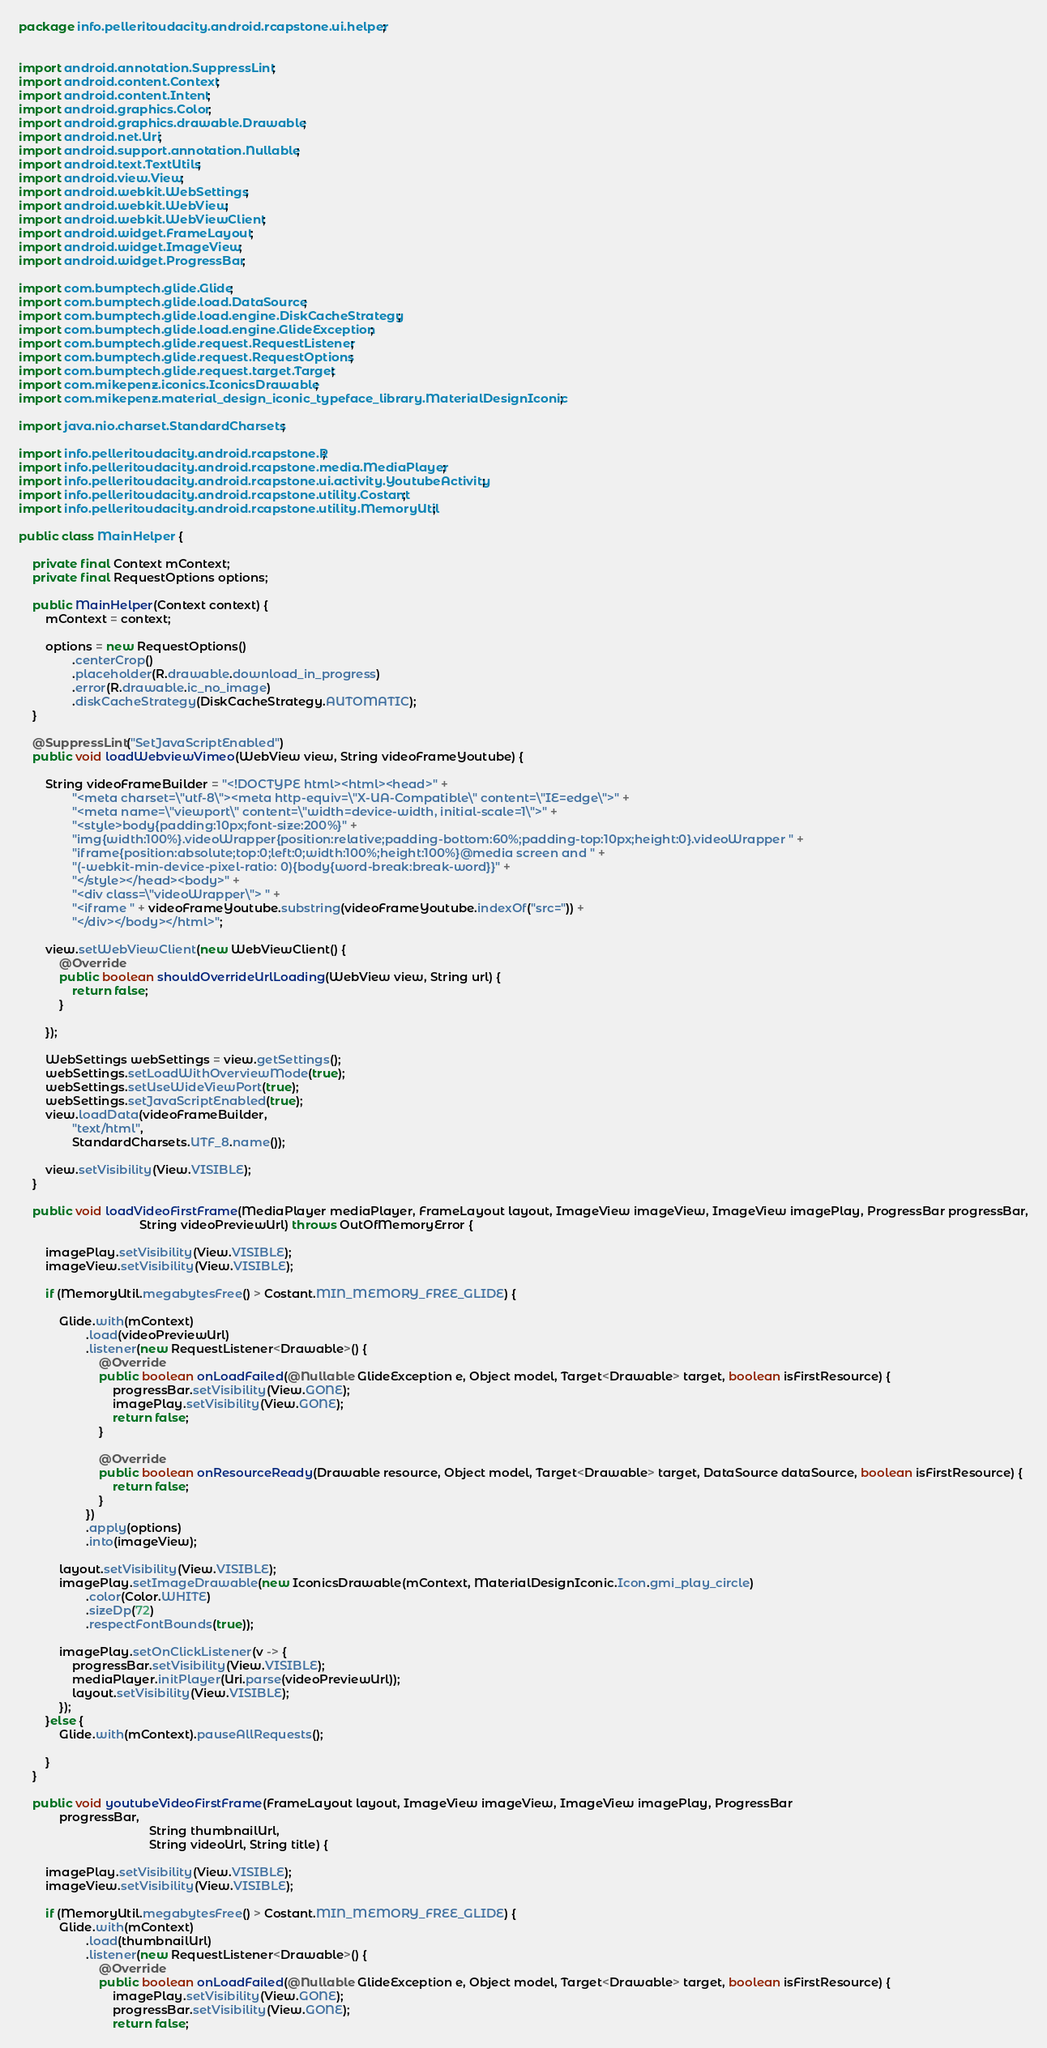<code> <loc_0><loc_0><loc_500><loc_500><_Java_>package info.pelleritoudacity.android.rcapstone.ui.helper;


import android.annotation.SuppressLint;
import android.content.Context;
import android.content.Intent;
import android.graphics.Color;
import android.graphics.drawable.Drawable;
import android.net.Uri;
import android.support.annotation.Nullable;
import android.text.TextUtils;
import android.view.View;
import android.webkit.WebSettings;
import android.webkit.WebView;
import android.webkit.WebViewClient;
import android.widget.FrameLayout;
import android.widget.ImageView;
import android.widget.ProgressBar;

import com.bumptech.glide.Glide;
import com.bumptech.glide.load.DataSource;
import com.bumptech.glide.load.engine.DiskCacheStrategy;
import com.bumptech.glide.load.engine.GlideException;
import com.bumptech.glide.request.RequestListener;
import com.bumptech.glide.request.RequestOptions;
import com.bumptech.glide.request.target.Target;
import com.mikepenz.iconics.IconicsDrawable;
import com.mikepenz.material_design_iconic_typeface_library.MaterialDesignIconic;

import java.nio.charset.StandardCharsets;

import info.pelleritoudacity.android.rcapstone.R;
import info.pelleritoudacity.android.rcapstone.media.MediaPlayer;
import info.pelleritoudacity.android.rcapstone.ui.activity.YoutubeActivity;
import info.pelleritoudacity.android.rcapstone.utility.Costant;
import info.pelleritoudacity.android.rcapstone.utility.MemoryUtil;

public class MainHelper {

    private final Context mContext;
    private final RequestOptions options;

    public MainHelper(Context context) {
        mContext = context;

        options = new RequestOptions()
                .centerCrop()
                .placeholder(R.drawable.download_in_progress)
                .error(R.drawable.ic_no_image)
                .diskCacheStrategy(DiskCacheStrategy.AUTOMATIC);
    }

    @SuppressLint("SetJavaScriptEnabled")
    public void loadWebviewVimeo(WebView view, String videoFrameYoutube) {

        String videoFrameBuilder = "<!DOCTYPE html><html><head>" +
                "<meta charset=\"utf-8\"><meta http-equiv=\"X-UA-Compatible\" content=\"IE=edge\">" +
                "<meta name=\"viewport\" content=\"width=device-width, initial-scale=1\">" +
                "<style>body{padding:10px;font-size:200%}" +
                "img{width:100%}.videoWrapper{position:relative;padding-bottom:60%;padding-top:10px;height:0}.videoWrapper " +
                "iframe{position:absolute;top:0;left:0;width:100%;height:100%}@media screen and " +
                "(-webkit-min-device-pixel-ratio: 0){body{word-break:break-word}}" +
                "</style></head><body>" +
                "<div class=\"videoWrapper\"> " +
                "<iframe " + videoFrameYoutube.substring(videoFrameYoutube.indexOf("src=")) +
                "</div></body></html>";

        view.setWebViewClient(new WebViewClient() {
            @Override
            public boolean shouldOverrideUrlLoading(WebView view, String url) {
                return false;
            }

        });

        WebSettings webSettings = view.getSettings();
        webSettings.setLoadWithOverviewMode(true);
        webSettings.setUseWideViewPort(true);
        webSettings.setJavaScriptEnabled(true);
        view.loadData(videoFrameBuilder,
                "text/html",
                StandardCharsets.UTF_8.name());

        view.setVisibility(View.VISIBLE);
    }

    public void loadVideoFirstFrame(MediaPlayer mediaPlayer, FrameLayout layout, ImageView imageView, ImageView imagePlay, ProgressBar progressBar,
                                    String videoPreviewUrl) throws OutOfMemoryError {

        imagePlay.setVisibility(View.VISIBLE);
        imageView.setVisibility(View.VISIBLE);

        if (MemoryUtil.megabytesFree() > Costant.MIN_MEMORY_FREE_GLIDE) {

            Glide.with(mContext)
                    .load(videoPreviewUrl)
                    .listener(new RequestListener<Drawable>() {
                        @Override
                        public boolean onLoadFailed(@Nullable GlideException e, Object model, Target<Drawable> target, boolean isFirstResource) {
                            progressBar.setVisibility(View.GONE);
                            imagePlay.setVisibility(View.GONE);
                            return false;
                        }

                        @Override
                        public boolean onResourceReady(Drawable resource, Object model, Target<Drawable> target, DataSource dataSource, boolean isFirstResource) {
                            return false;
                        }
                    })
                    .apply(options)
                    .into(imageView);

            layout.setVisibility(View.VISIBLE);
            imagePlay.setImageDrawable(new IconicsDrawable(mContext, MaterialDesignIconic.Icon.gmi_play_circle)
                    .color(Color.WHITE)
                    .sizeDp(72)
                    .respectFontBounds(true));

            imagePlay.setOnClickListener(v -> {
                progressBar.setVisibility(View.VISIBLE);
                mediaPlayer.initPlayer(Uri.parse(videoPreviewUrl));
                layout.setVisibility(View.VISIBLE);
            });
        }else {
            Glide.with(mContext).pauseAllRequests();

        }
    }

    public void youtubeVideoFirstFrame(FrameLayout layout, ImageView imageView, ImageView imagePlay, ProgressBar
            progressBar,
                                       String thumbnailUrl,
                                       String videoUrl, String title) {

        imagePlay.setVisibility(View.VISIBLE);
        imageView.setVisibility(View.VISIBLE);

        if (MemoryUtil.megabytesFree() > Costant.MIN_MEMORY_FREE_GLIDE) {
            Glide.with(mContext)
                    .load(thumbnailUrl)
                    .listener(new RequestListener<Drawable>() {
                        @Override
                        public boolean onLoadFailed(@Nullable GlideException e, Object model, Target<Drawable> target, boolean isFirstResource) {
                            imagePlay.setVisibility(View.GONE);
                            progressBar.setVisibility(View.GONE);
                            return false;</code> 